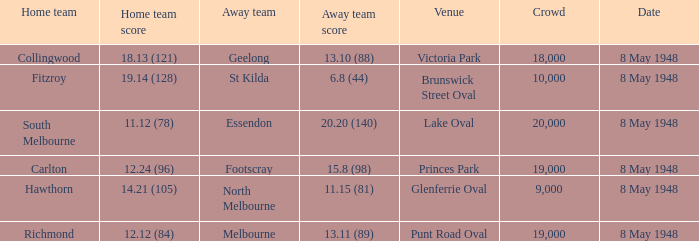How many spectators were at the game when the away team scored 15.8 (98)? 19000.0. 